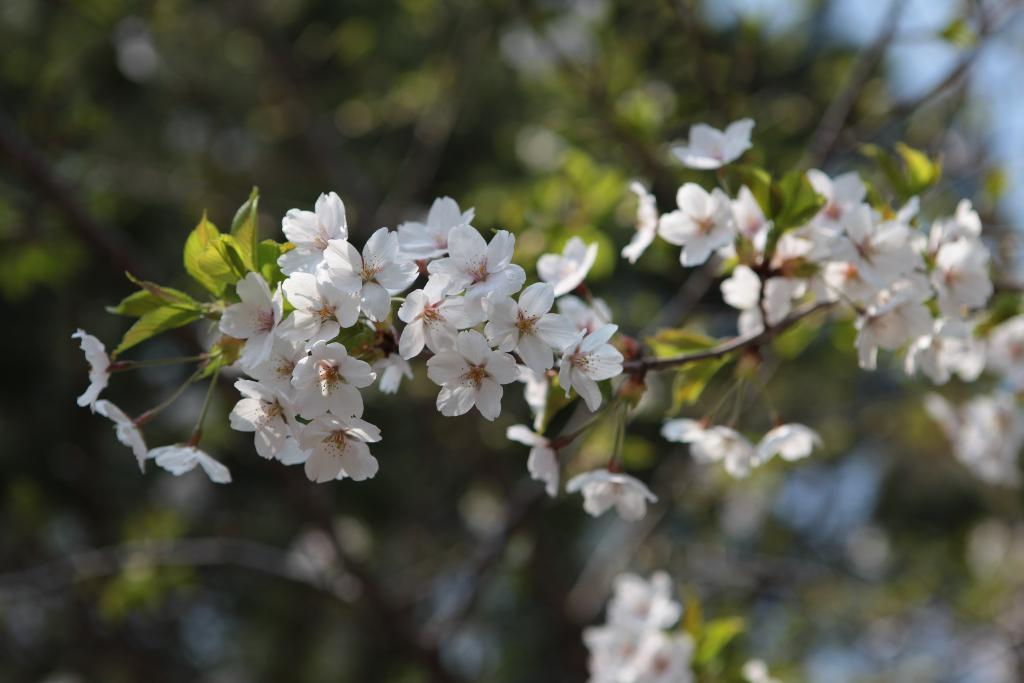What is the main subject of the image? There is a group of flowers in the image. Are there any other plants or vegetation in the image? Yes, there is a tree in the image. Can you describe the background of the image? The background of the image is blurred. How many jellyfish can be seen swimming near the tree in the image? There are no jellyfish present in the image; it features a group of flowers and a tree. Is there a parcel being delivered to the flowers in the image? There is no parcel or delivery mentioned or depicted in the image. 